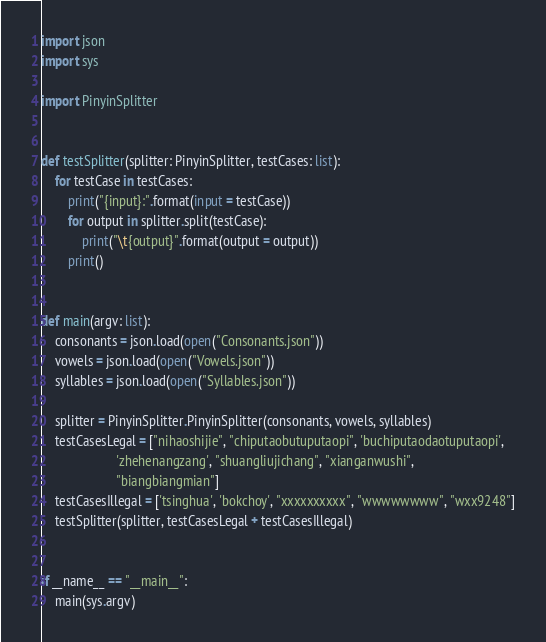<code> <loc_0><loc_0><loc_500><loc_500><_Python_>import json
import sys

import PinyinSplitter


def testSplitter(splitter: PinyinSplitter, testCases: list):
    for testCase in testCases:
        print("{input}:".format(input = testCase))
        for output in splitter.split(testCase):
            print("\t{output}".format(output = output))
        print()


def main(argv: list):
    consonants = json.load(open("Consonants.json"))
    vowels = json.load(open("Vowels.json"))
    syllables = json.load(open("Syllables.json"))

    splitter = PinyinSplitter.PinyinSplitter(consonants, vowels, syllables)
    testCasesLegal = ["nihaoshijie", "chiputaobutuputaopi", 'buchiputaodaotuputaopi',
                      'zhehenangzang', "shuangliujichang", "xianganwushi",
                      "biangbiangmian"]
    testCasesIllegal = ['tsinghua', 'bokchoy', "xxxxxxxxxx", "wwwwwwww", "wxx9248"]
    testSplitter(splitter, testCasesLegal + testCasesIllegal)


if __name__ == "__main__":
    main(sys.argv)
</code> 